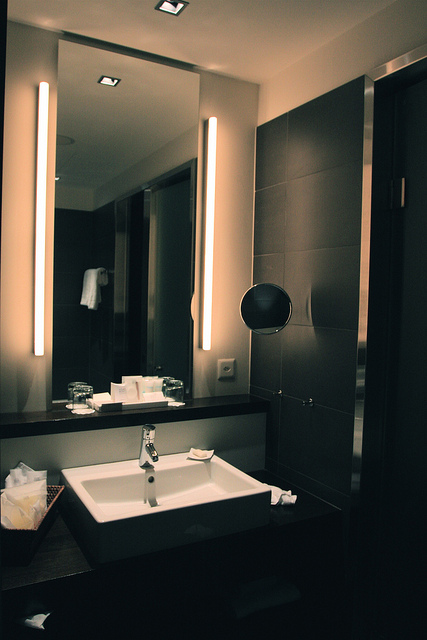What type of room is displayed in the image? The image displays a sleek and modern bathroom, featuring contemporary fixtures and a minimalist design. 